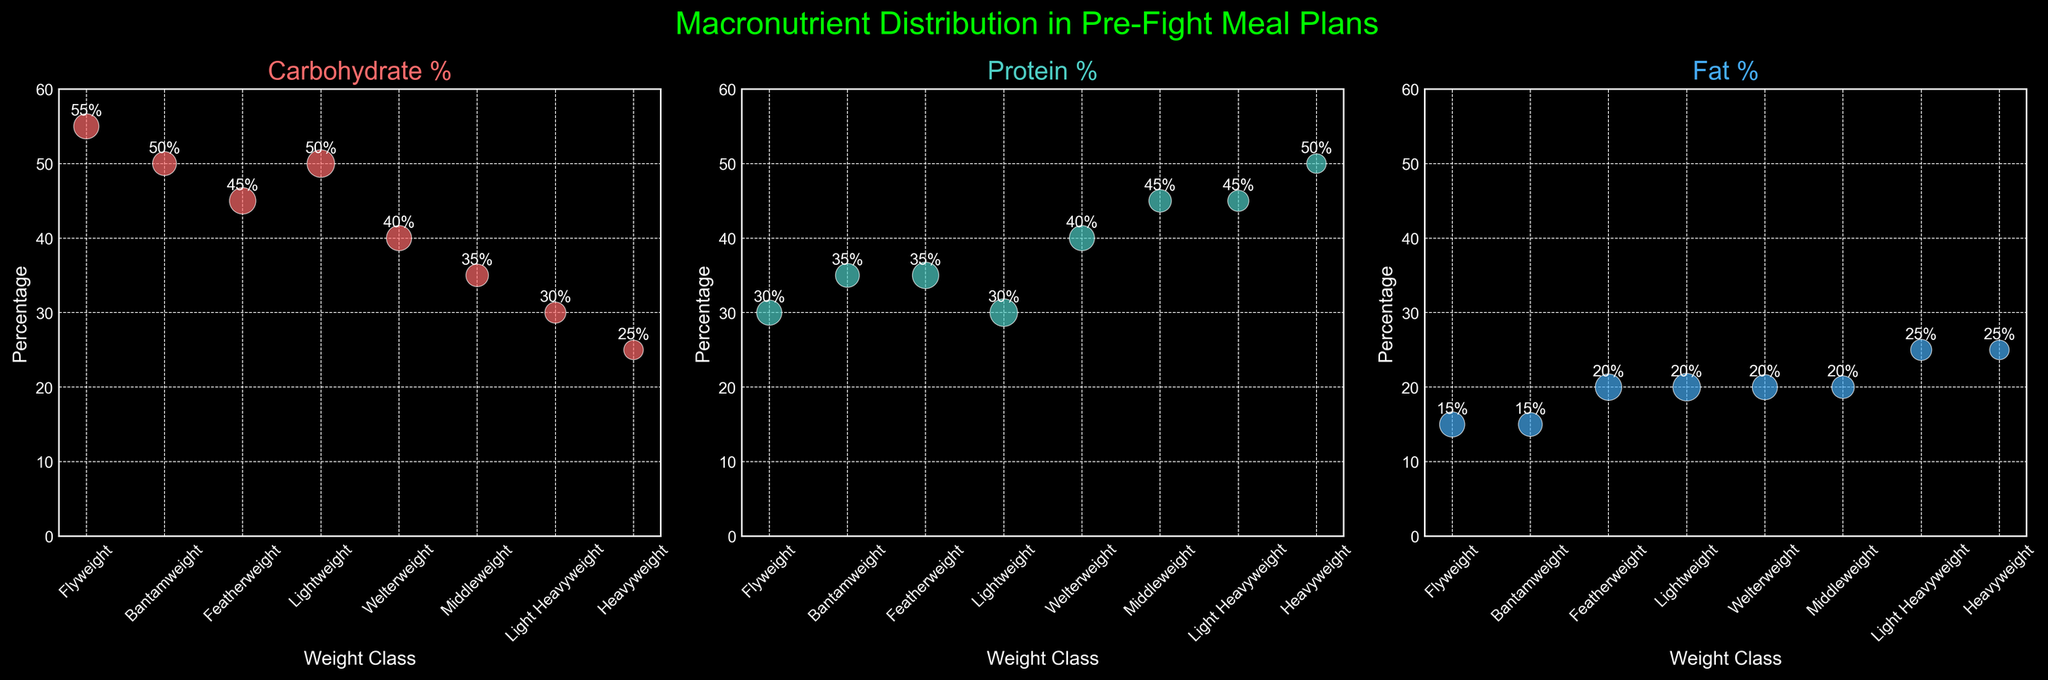What's the title of the figure? The title of the figure can be found at the top and helps provide context for the data presented. The title is "Macronutrient Distribution in Pre-Fight Meal Plans".
Answer: Macronutrient Distribution in Pre-Fight Meal Plans Which weight class has the highest percentage of protein? To find the weight class with the highest protein percentage, look for the highest point in the "Protein %" subplot. The highest value is at the Heavyweight class with 50%.
Answer: Heavyweight What is the carbohydrate percentage for Bantamweight? In the "Carbohydrate %" subplot, find the Bantamweight point on the x-axis and check its y-coordinate. The y-coordinate is labeled as 50%.
Answer: 50% Which nutrient has the smallest range of percentages across weight classes? The range is calculated by the difference between the maximum and minimum values of each nutrient. Carbohydrates range from 25% to 55%, proteins from 30% to 50%, and fats from 15% to 25%. The smallest range is for fat, ranging from 15% to 25%, which is a 10% range.
Answer: Fat What is the average fat percentage across all weight classes? Compute the average of the fat percentages given for all classes. The percentages are 15, 15, 20, 20, 20, 20, 25, 25. Summing these gives 160, and dividing by the number of classes (8) gives 160/8 = 20%.
Answer: 20% Which weight class has an equal proportion of two nutrients? Scan the subplots to find two nutrients with matching percentages for any weight class. Welterweight has equal carbohydrate (40%) and protein (40%) percentages.
Answer: Welterweight Which weight class has the lowest carbohydrate percentage? In the "Carbohydrate %" subplot, find the lowest y-coordinate point. The lowest value is 25% for the Heavyweight class.
Answer: Heavyweight How does the macronutrient distribution change from Flyweight to Heavyweight? By examining all subplots, summarize the trend: Carbohydrates decrease from 55% to 25%, Proteins increase from 30% to 50%, and Fats increase from 15% to 25%.
Answer: Carbs decrease, proteins increase, fats increase What is the total sample size across all weight classes? Sum the sample sizes for all weight classes: 50 + 45 + 55 + 60 + 50 + 40 + 35 + 30 = 365.
Answer: 365 How many weight classes have a protein percentage of 45% or more? Identify protein percentages in the "Protein %" subplot that are 45% or more. The weight classes are Middleweight (45%), Light Heavyweight (45%), and Heavyweight (50%). There are three such classes.
Answer: 3 